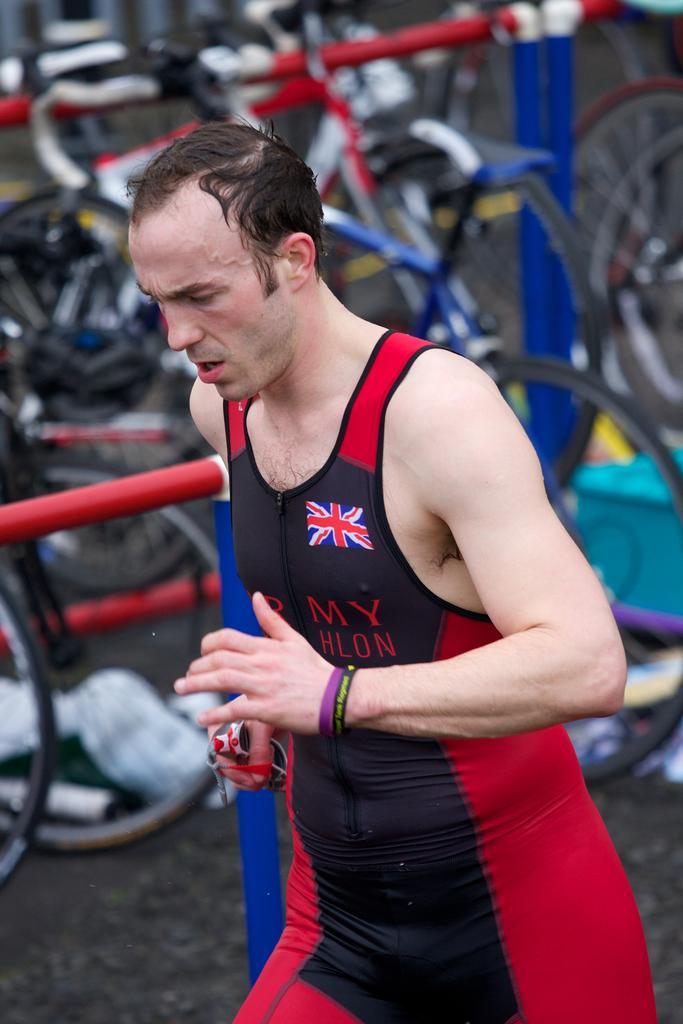Could you give a brief overview of what you see in this image? As we can see in the image in the front there is a man. In the background there are bicycles. The background is little blur. 